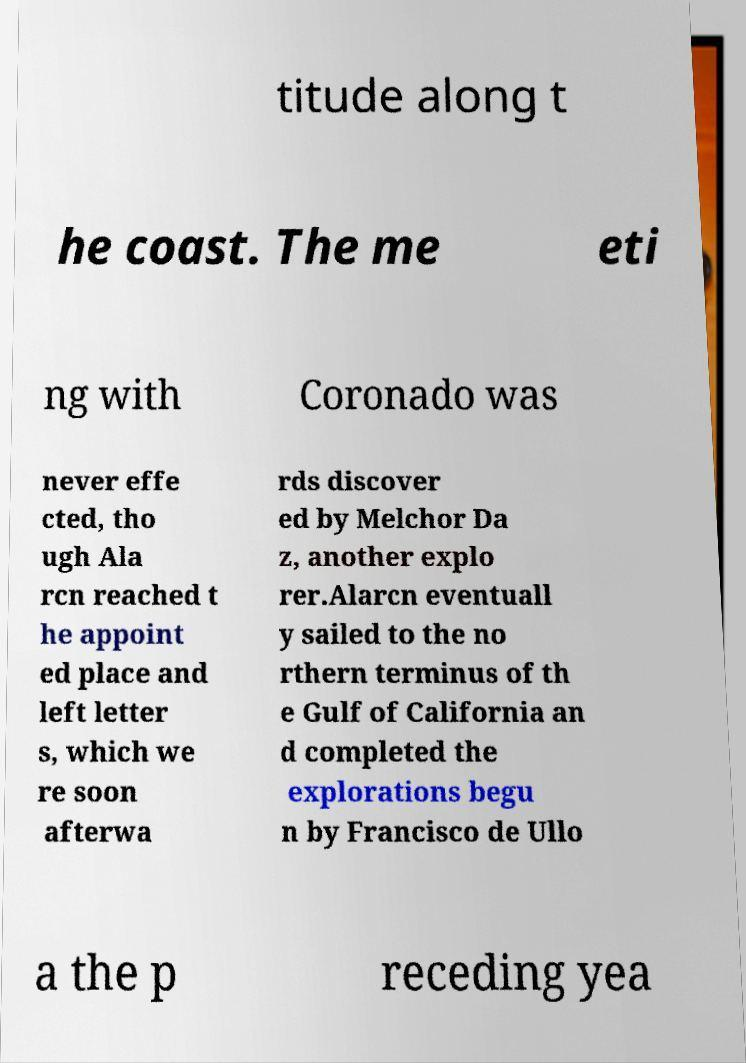What messages or text are displayed in this image? I need them in a readable, typed format. titude along t he coast. The me eti ng with Coronado was never effe cted, tho ugh Ala rcn reached t he appoint ed place and left letter s, which we re soon afterwa rds discover ed by Melchor Da z, another explo rer.Alarcn eventuall y sailed to the no rthern terminus of th e Gulf of California an d completed the explorations begu n by Francisco de Ullo a the p receding yea 